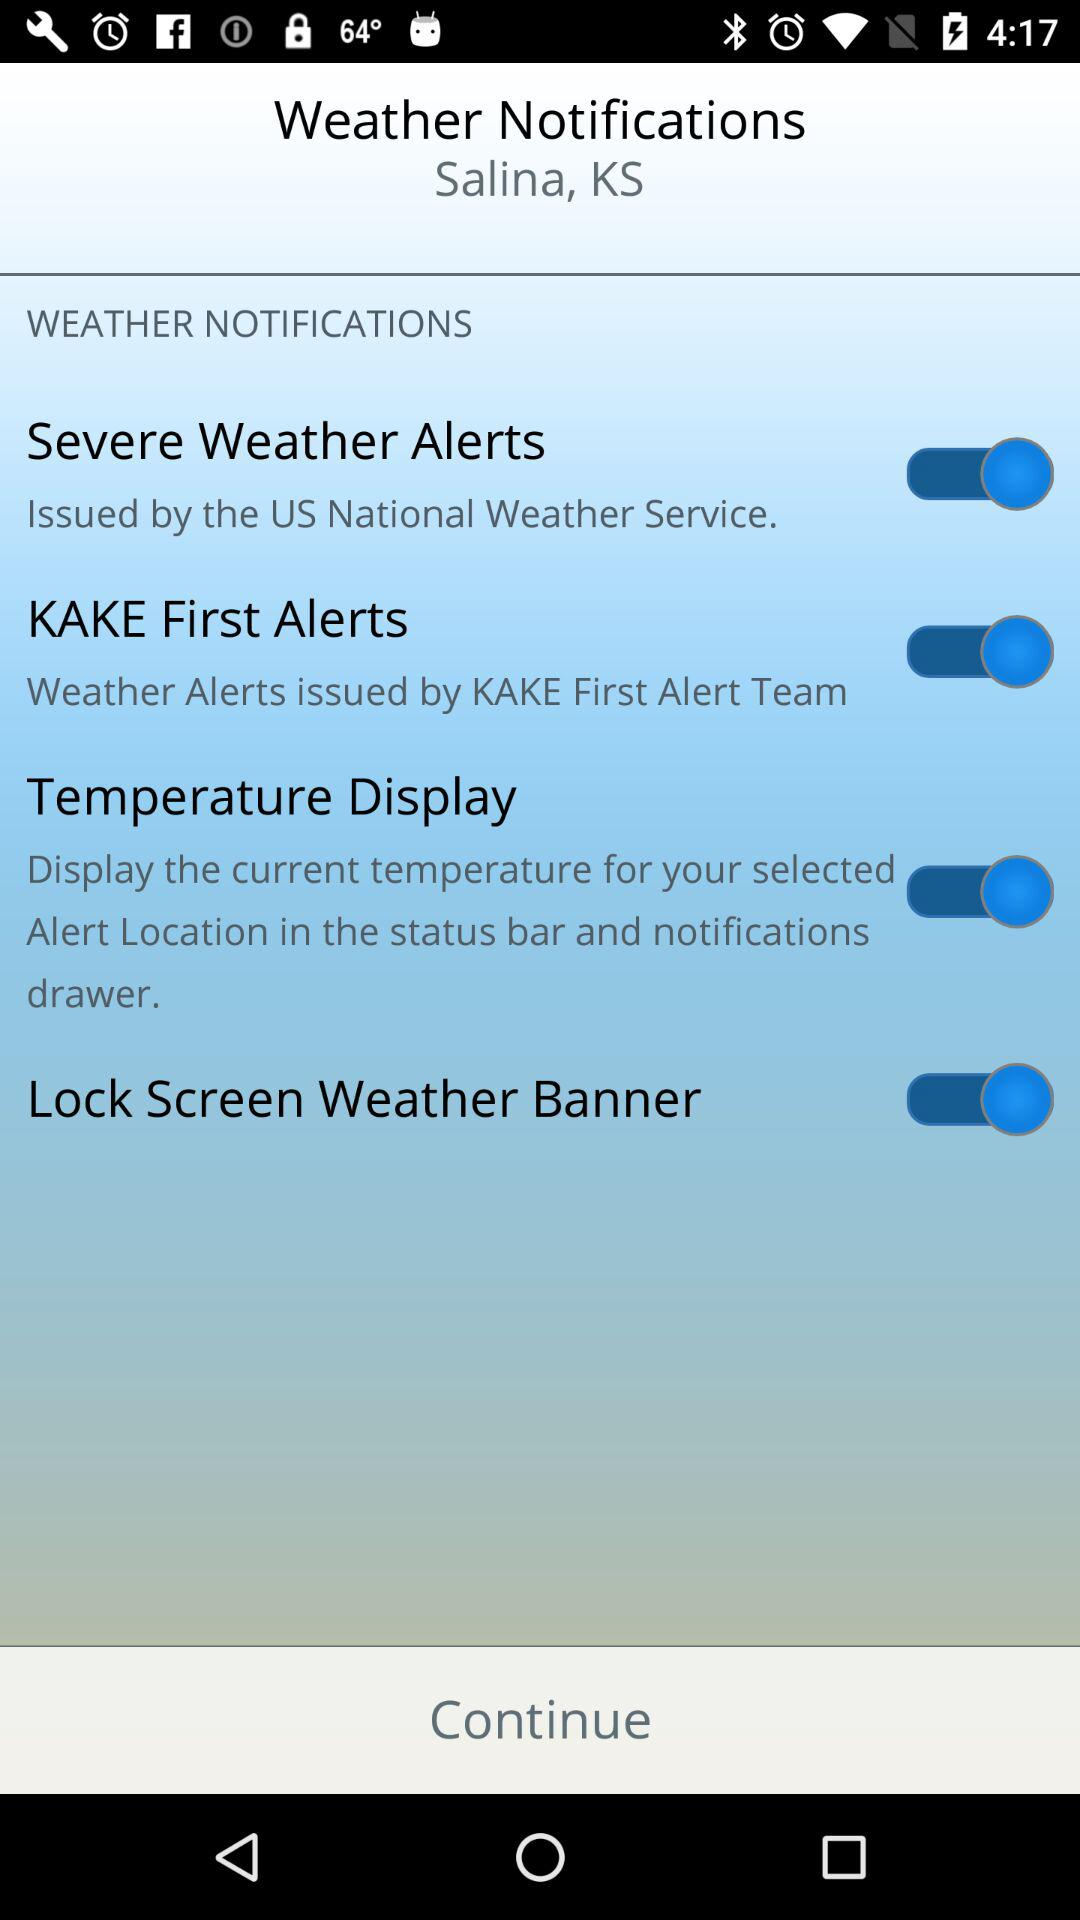What is the status of "Temperature Display"? The status of "Temperature Display" is "on". 